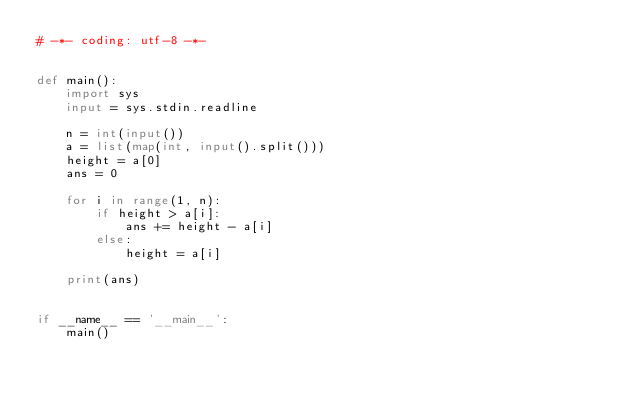<code> <loc_0><loc_0><loc_500><loc_500><_Python_># -*- coding: utf-8 -*-


def main():
    import sys
    input = sys.stdin.readline

    n = int(input())
    a = list(map(int, input().split()))
    height = a[0]
    ans = 0

    for i in range(1, n):
        if height > a[i]:
            ans += height - a[i]
        else:
            height = a[i]

    print(ans)


if __name__ == '__main__':
    main()
</code> 